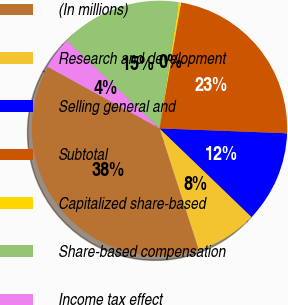Convert chart. <chart><loc_0><loc_0><loc_500><loc_500><pie_chart><fcel>(In millions)<fcel>Research and development<fcel>Selling general and<fcel>Subtotal<fcel>Capitalized share-based<fcel>Share-based compensation<fcel>Income tax effect<nl><fcel>38.0%<fcel>7.82%<fcel>11.59%<fcel>22.91%<fcel>0.28%<fcel>15.36%<fcel>4.05%<nl></chart> 